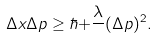<formula> <loc_0><loc_0><loc_500><loc_500>\Delta x \Delta p \geq \hbar { + } \frac { \lambda } { } ( \Delta p ) ^ { 2 } .</formula> 